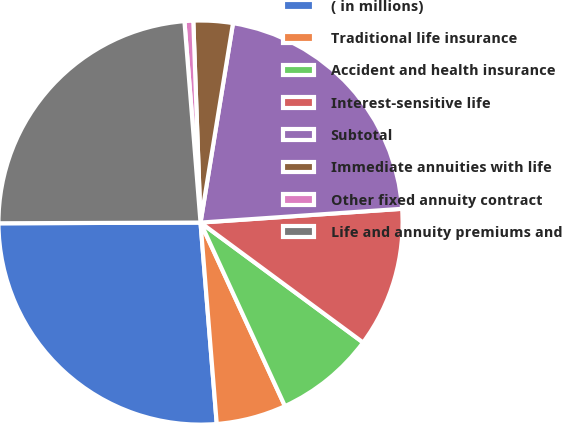Convert chart to OTSL. <chart><loc_0><loc_0><loc_500><loc_500><pie_chart><fcel>( in millions)<fcel>Traditional life insurance<fcel>Accident and health insurance<fcel>Interest-sensitive life<fcel>Subtotal<fcel>Immediate annuities with life<fcel>Other fixed annuity contract<fcel>Life and annuity premiums and<nl><fcel>26.22%<fcel>5.58%<fcel>8.02%<fcel>11.2%<fcel>21.34%<fcel>3.14%<fcel>0.7%<fcel>23.78%<nl></chart> 